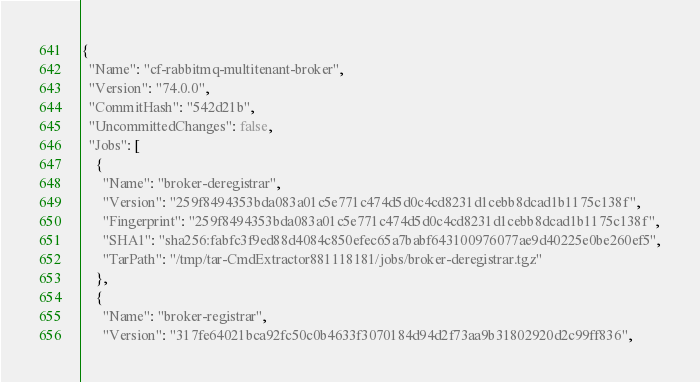Convert code to text. <code><loc_0><loc_0><loc_500><loc_500><_YAML_>{
  "Name": "cf-rabbitmq-multitenant-broker",
  "Version": "74.0.0",
  "CommitHash": "542d21b",
  "UncommittedChanges": false,
  "Jobs": [
    {
      "Name": "broker-deregistrar",
      "Version": "259f8494353bda083a01c5e771c474d5d0c4cd8231d1cebb8dcad1b1175c138f",
      "Fingerprint": "259f8494353bda083a01c5e771c474d5d0c4cd8231d1cebb8dcad1b1175c138f",
      "SHA1": "sha256:fabfc3f9ed88d4084c850efec65a7babf643100976077ae9d40225e0be260ef5",
      "TarPath": "/tmp/tar-CmdExtractor881118181/jobs/broker-deregistrar.tgz"
    },
    {
      "Name": "broker-registrar",
      "Version": "317fe64021bca92fc50c0b4633f3070184d94d2f73aa9b31802920d2c99ff836",</code> 